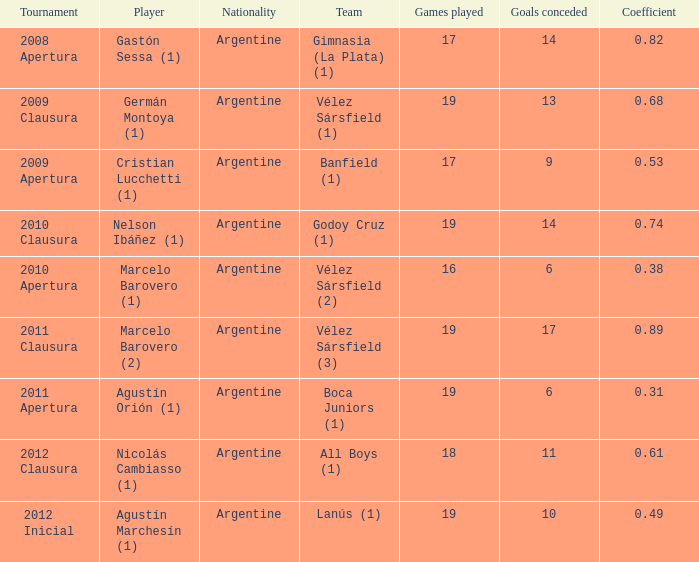What is the nationality of the 2012 clausura  tournament? Argentine. 